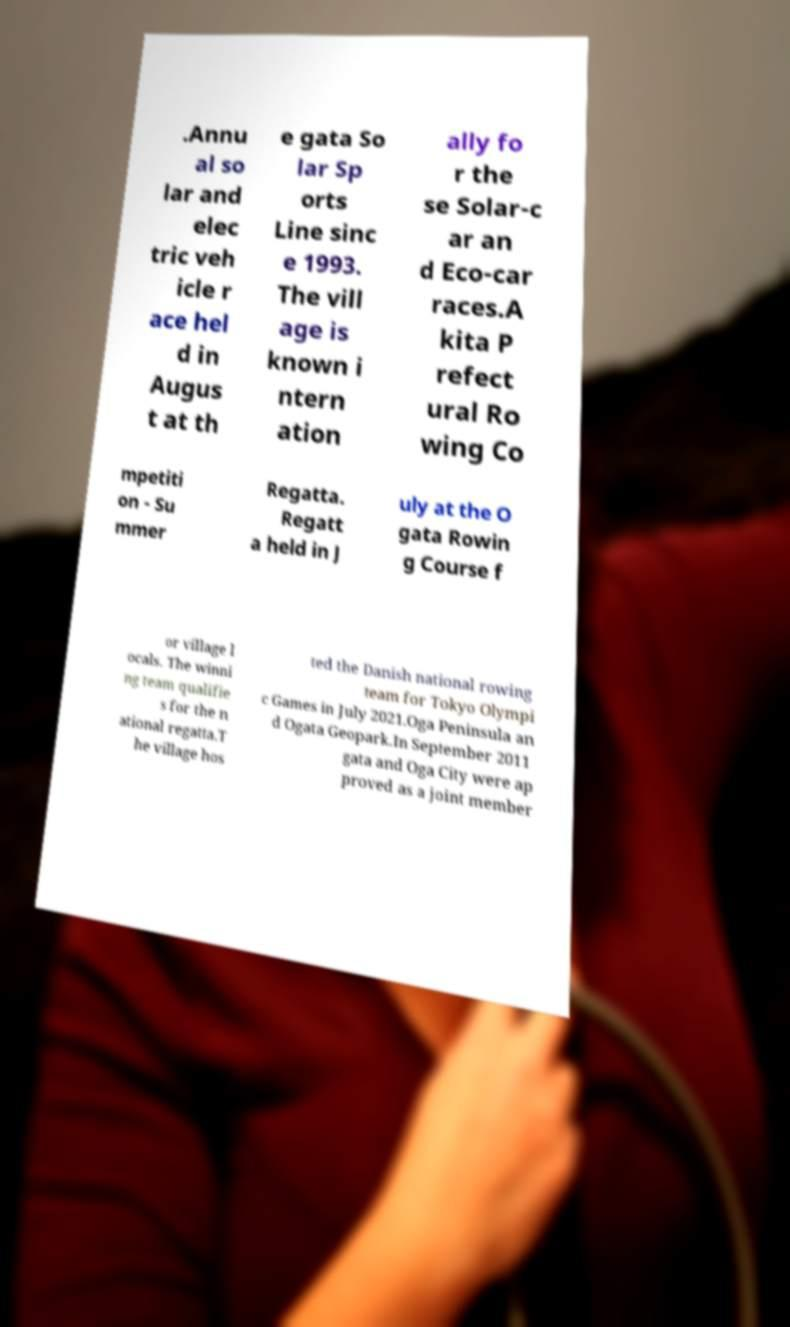I need the written content from this picture converted into text. Can you do that? .Annu al so lar and elec tric veh icle r ace hel d in Augus t at th e gata So lar Sp orts Line sinc e 1993. The vill age is known i ntern ation ally fo r the se Solar-c ar an d Eco-car races.A kita P refect ural Ro wing Co mpetiti on - Su mmer Regatta. Regatt a held in J uly at the O gata Rowin g Course f or village l ocals. The winni ng team qualifie s for the n ational regatta.T he village hos ted the Danish national rowing team for Tokyo Olympi c Games in July 2021.Oga Peninsula an d Ogata Geopark.In September 2011 gata and Oga City were ap proved as a joint member 